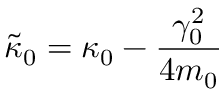<formula> <loc_0><loc_0><loc_500><loc_500>\tilde { \kappa } _ { 0 } = \kappa _ { 0 } - \frac { \gamma _ { 0 } ^ { 2 } } { 4 m _ { 0 } }</formula> 